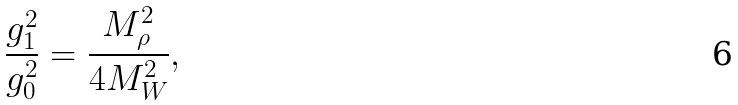Convert formula to latex. <formula><loc_0><loc_0><loc_500><loc_500>\frac { g ^ { 2 } _ { 1 } } { g ^ { 2 } _ { 0 } } = \frac { M ^ { 2 } _ { \rho } } { 4 M ^ { 2 } _ { W } } ,</formula> 